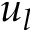<formula> <loc_0><loc_0><loc_500><loc_500>u _ { l }</formula> 